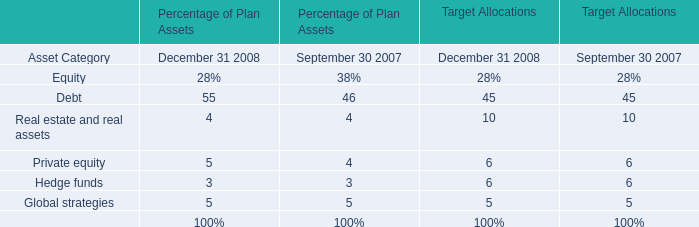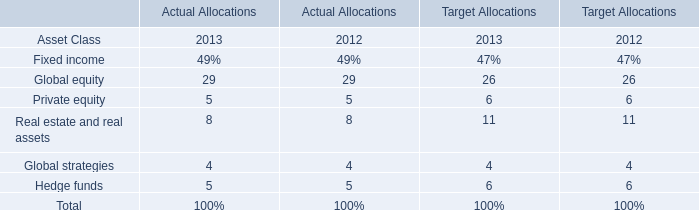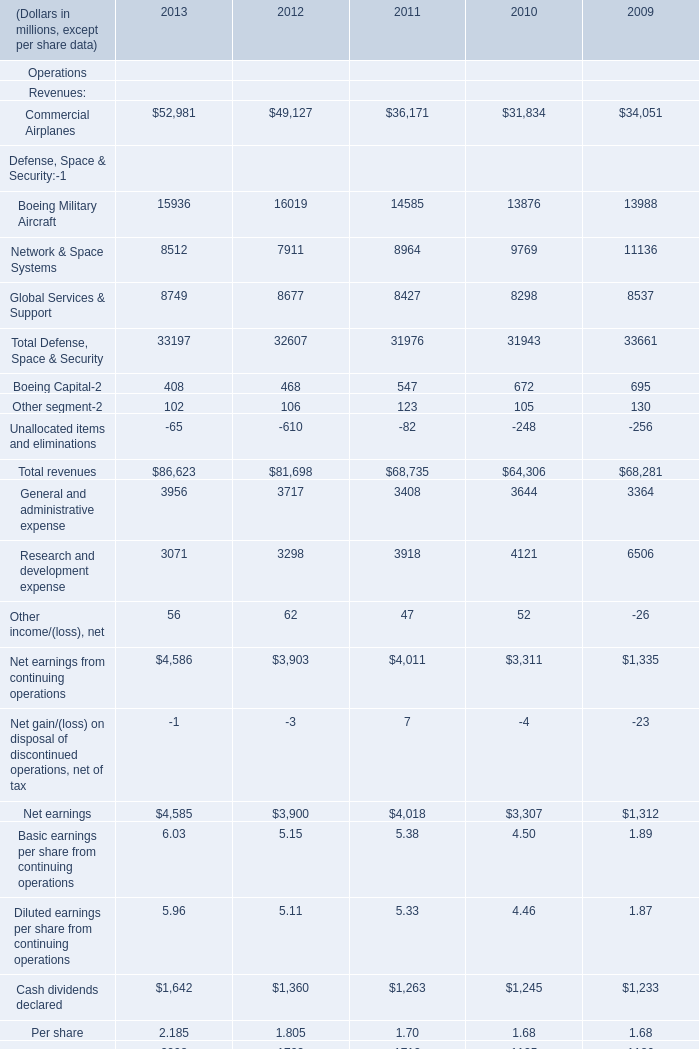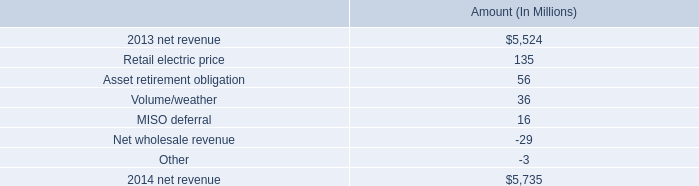What's the average of Revenues:Commercial Airplanes in 2012 and 2011 for Operations? (in million) 
Computations: ((49127 + 36171) / 2)
Answer: 42649.0. 